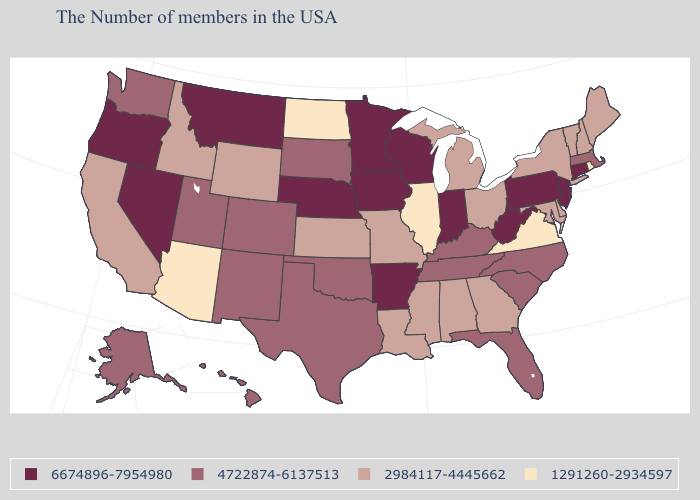Is the legend a continuous bar?
Concise answer only. No. What is the value of Alabama?
Concise answer only. 2984117-4445662. Name the states that have a value in the range 1291260-2934597?
Write a very short answer. Rhode Island, Virginia, Illinois, North Dakota, Arizona. Among the states that border North Carolina , which have the lowest value?
Keep it brief. Virginia. Name the states that have a value in the range 4722874-6137513?
Be succinct. Massachusetts, North Carolina, South Carolina, Florida, Kentucky, Tennessee, Oklahoma, Texas, South Dakota, Colorado, New Mexico, Utah, Washington, Alaska, Hawaii. Which states have the lowest value in the USA?
Keep it brief. Rhode Island, Virginia, Illinois, North Dakota, Arizona. What is the value of Indiana?
Quick response, please. 6674896-7954980. How many symbols are there in the legend?
Give a very brief answer. 4. What is the value of Kansas?
Write a very short answer. 2984117-4445662. Does the first symbol in the legend represent the smallest category?
Give a very brief answer. No. Name the states that have a value in the range 6674896-7954980?
Concise answer only. Connecticut, New Jersey, Pennsylvania, West Virginia, Indiana, Wisconsin, Arkansas, Minnesota, Iowa, Nebraska, Montana, Nevada, Oregon. What is the value of Washington?
Answer briefly. 4722874-6137513. What is the lowest value in the USA?
Write a very short answer. 1291260-2934597. 